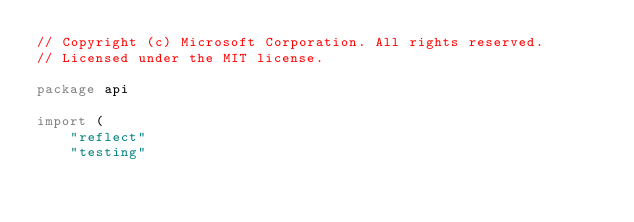<code> <loc_0><loc_0><loc_500><loc_500><_Go_>// Copyright (c) Microsoft Corporation. All rights reserved.
// Licensed under the MIT license.

package api

import (
	"reflect"
	"testing"
</code> 